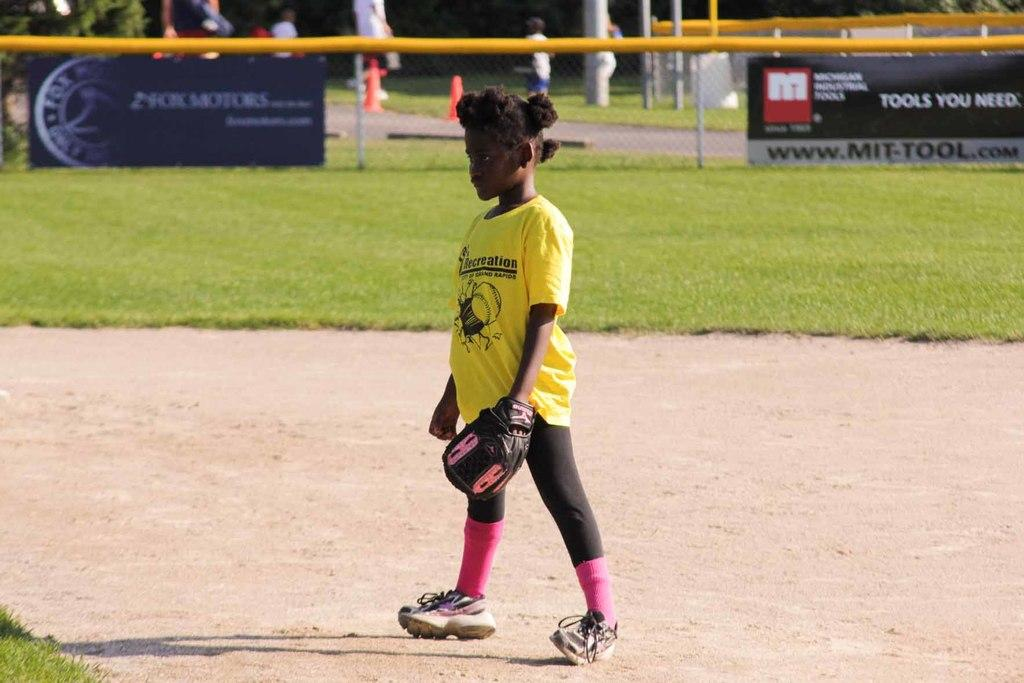<image>
Describe the image concisely. a kid with the word recreation on their shirt 